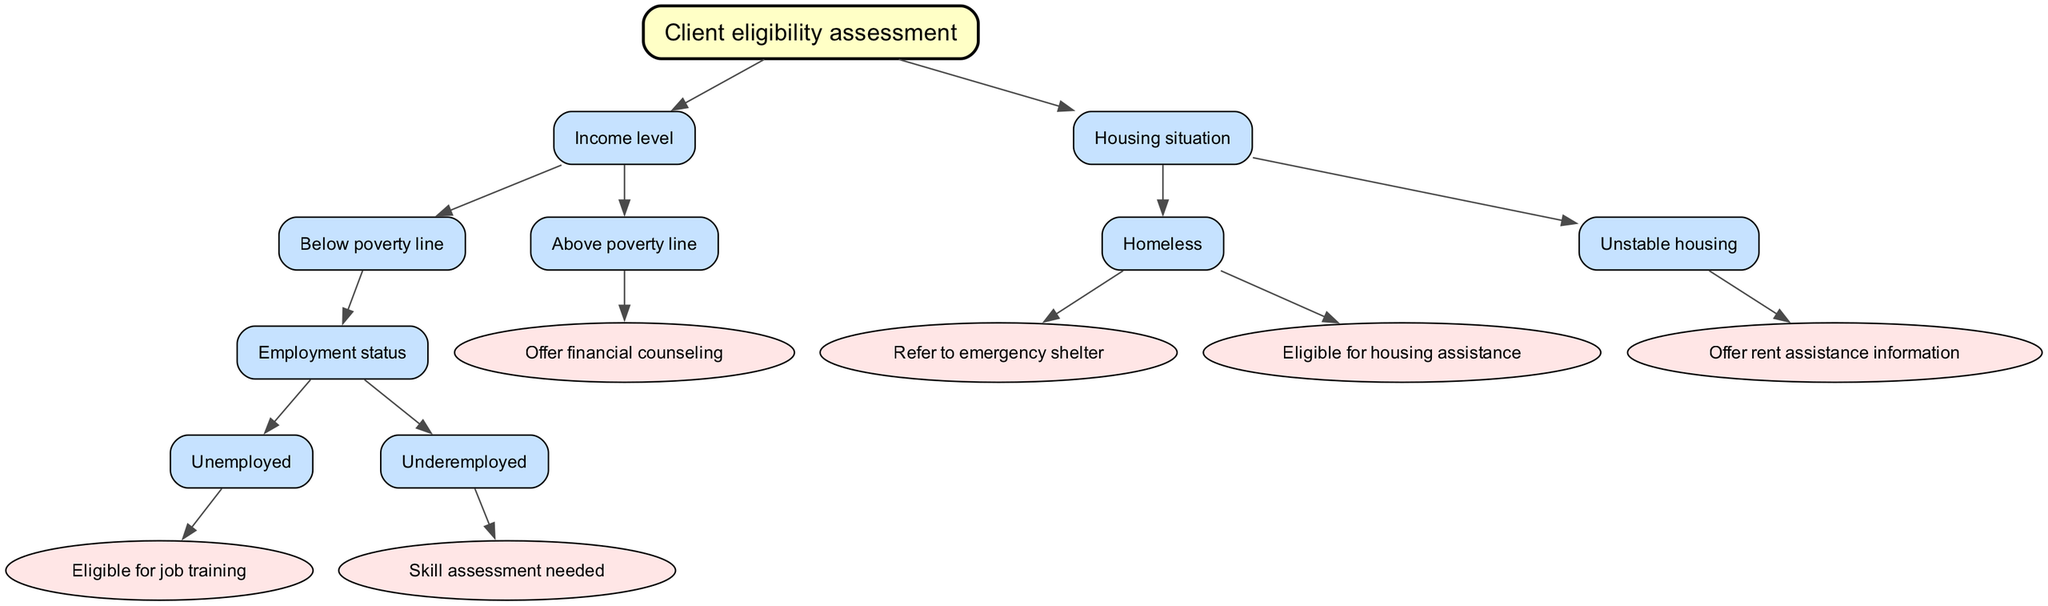What is the root node of the decision tree? The root node of the decision tree is labeled "Client eligibility assessment", which sets the context for the evaluation of client eligibility for additional services.
Answer: Client eligibility assessment How many child nodes does the "Income level" node have? The "Income level" node has two child nodes: "Below poverty line" and "Above poverty line", indicating two distinct income categories for assessment.
Answer: 2 What service is offered if a client is above the poverty line? If a client is above the poverty line, the diagram indicates that the service offered is "financial counseling", which is listed under that node.
Answer: Financial counseling What are the two situations under the "Housing situation" node? The "Housing situation" node has two situations: "Homeless" and "Unstable housing", which represent different housing circumstances eligible for different services.
Answer: Homeless, Unstable housing What action is taken if the client is homeless? If the client is homeless, the diagram provides two potential actions: "Refer to emergency shelter" and "Eligible for housing assistance", indicating that both options are available for homeless clients.
Answer: Refer to emergency shelter, Eligible for housing assistance What does the decision tree suggest for an underemployed client? The decision tree indicates that for an underemployed client, a "skill assessment needed" is identified, suggesting further evaluation of their skills is required.
Answer: Skill assessment needed If a client is unemployed and below the poverty line, what are they eligible for? For a client who is unemployed and below the poverty line, the decision tree specifies they are "Eligible for job training", which is essential support for improving employment opportunities.
Answer: Eligible for job training What type of assistance is provided to someone with unstable housing? If the client has unstable housing, the diagram suggests they will receive "rent assistance information", which can help them manage their housing situation.
Answer: Rent assistance information 